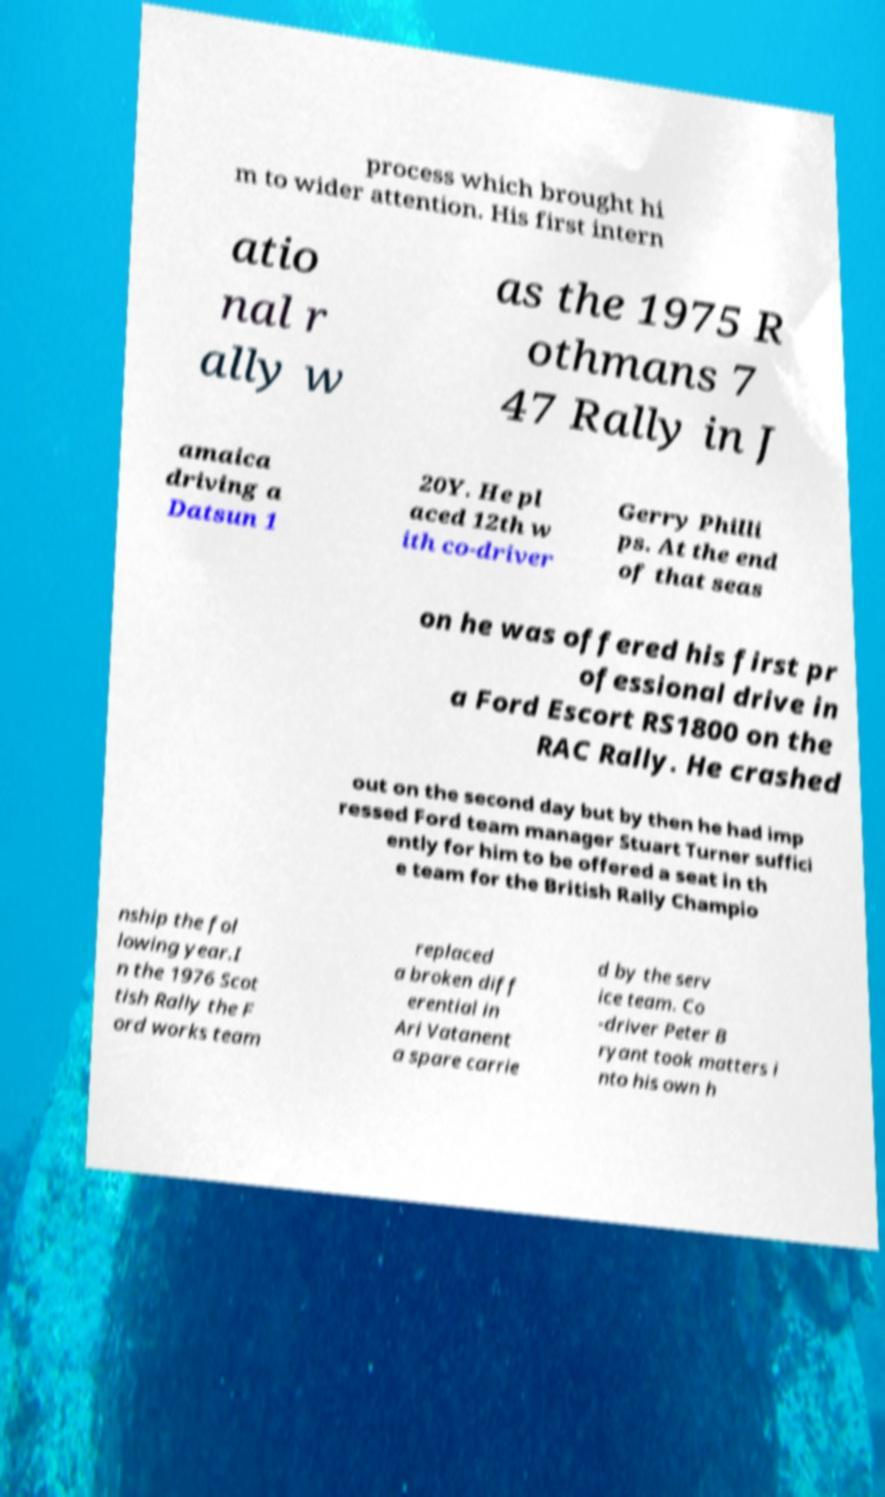Could you extract and type out the text from this image? process which brought hi m to wider attention. His first intern atio nal r ally w as the 1975 R othmans 7 47 Rally in J amaica driving a Datsun 1 20Y. He pl aced 12th w ith co-driver Gerry Philli ps. At the end of that seas on he was offered his first pr ofessional drive in a Ford Escort RS1800 on the RAC Rally. He crashed out on the second day but by then he had imp ressed Ford team manager Stuart Turner suffici ently for him to be offered a seat in th e team for the British Rally Champio nship the fol lowing year.I n the 1976 Scot tish Rally the F ord works team replaced a broken diff erential in Ari Vatanent a spare carrie d by the serv ice team. Co -driver Peter B ryant took matters i nto his own h 